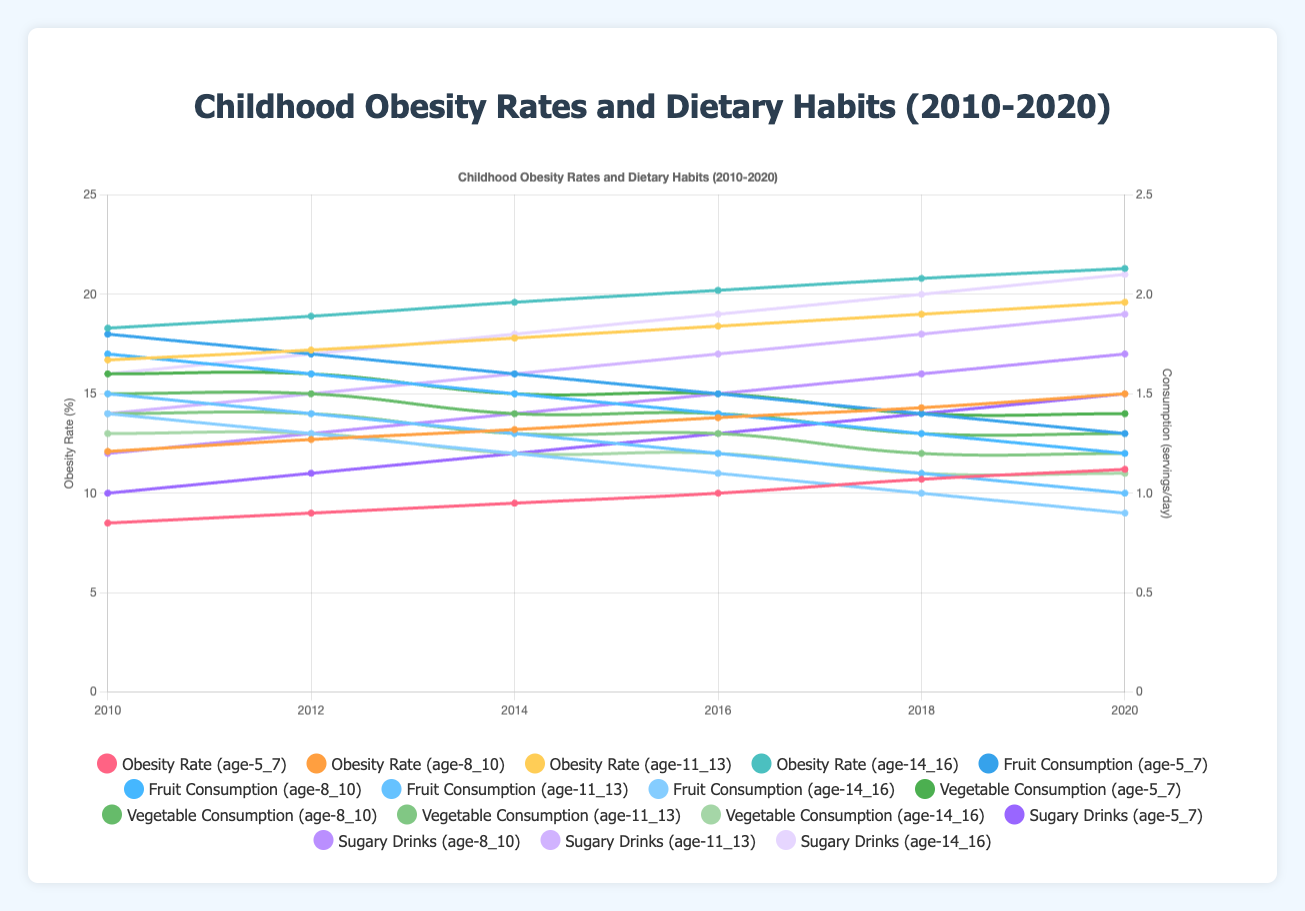What is the trend in obesity rates for the age group 5-7 from 2010 to 2020? The line representing the obesity rate for age group 5-7 shows a steady increase from 8.5% in 2010 to 11.2% in 2020.
Answer: Steady increase How does the fruit consumption trend for age group 11-13 compare to their obesity rate trend during the same period? The fruit consumption for age group 11-13 shows a declining trend from 1.5 servings/day in 2010 to 1.0 servings/day in 2020, while their obesity rate shows an increasing trend from 16.7% in 2010 to 19.6% in 2020.
Answer: Fruit consumption declines while obesity increases Which age group had the highest obesity rate in 2020? The line for the age group 14-16 has the highest point at 21.3% in 2020 compared to all other age groups.
Answer: Age 14-16 How do sugary drink consumption trends for all age groups compare across the years 2010 to 2020? All age groups show an increasing trend in sugary drink consumption from 2010 to 2020, with age 14-16 having the highest increase from 1.6 servings/day in 2010 to 2.1 servings/day in 2020.
Answer: Increasing trend for all age groups By how much did the obesity rate for age group 8-10 increase from 2010 to 2020, and how does this compare to the increase in sugary drink consumption for the same group? The obesity rate for age group 8-10 increased from 12.1% in 2010 to 15.0% in 2020, a difference of 2.9%. Their sugary drink consumption increased from 1.2 servings/day to 1.7 servings/day, a difference of 0.5 servings/day.
Answer: Obesity rate increased by 2.9%, sugary drink consumption by 0.5 What is the difference in vegetable consumption between 2010 and 2020 for age group 14-16? In 2010, vegetable consumption for age group 14-16 was 1.3 servings/day. By 2020, it was 1.1 servings/day. The difference is 1.3 - 1.1 = 0.2 servings/day.
Answer: 0.2 servings/day Which age group showed the sharpest decline in fruit consumption from 2018 to 2020? The age group 14-16 had fruit consumption drop from 1.0 servings/day in 2018 to 0.9 servings/day in 2020, a decline of 0.1 servings/day. This is the largest decline compared to other age groups within this period.
Answer: Age 14-16 Do vegetable consumption trends support the changes in obesity rates for age 8-10 from 2010 to 2020? Vegetable consumption for age group 8-10 decreased slightly from 1.5 servings/day in 2010 to 1.3 servings/day in 2020. This decrease coincides with an increase in obesity rates from 12.1% to 15.0%. The declining vegetable consumption aligns with rising obesity rates.
Answer: Yes, declining vegetable consumption aligns with rising obesity rates 